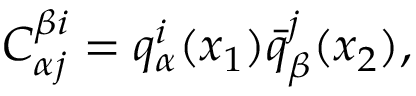<formula> <loc_0><loc_0><loc_500><loc_500>C _ { \alpha j } ^ { \beta i } = q _ { \alpha } ^ { i } ( x _ { 1 } ) \bar { q } _ { \beta } ^ { j } ( x _ { 2 } ) ,</formula> 